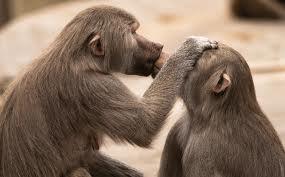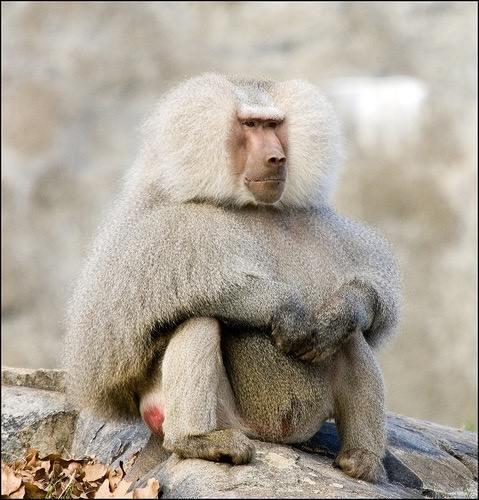The first image is the image on the left, the second image is the image on the right. Evaluate the accuracy of this statement regarding the images: "There are more primates in the image on the left.". Is it true? Answer yes or no. Yes. The first image is the image on the left, the second image is the image on the right. Analyze the images presented: Is the assertion "The right image shows a silvery long haired monkey sitting on its pink rear, and the left image shows two monkeys with matching coloring." valid? Answer yes or no. Yes. 